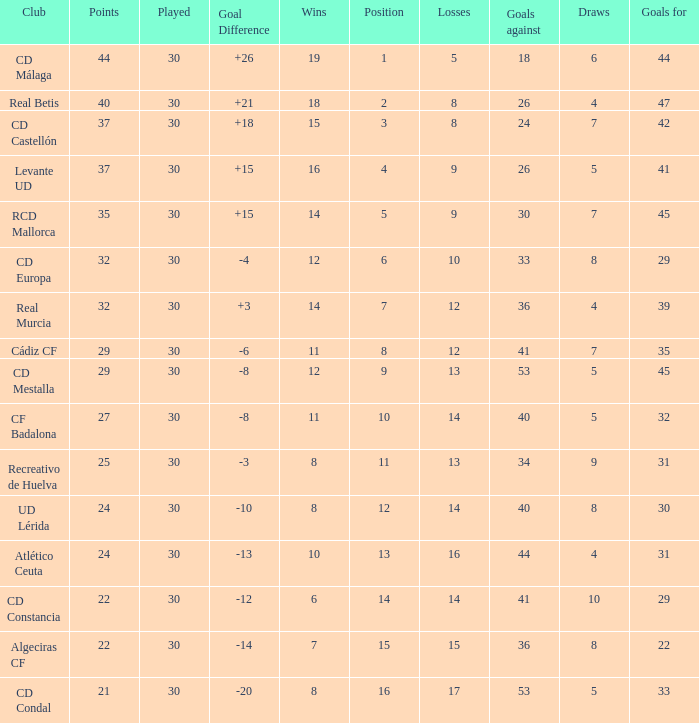When the goal difference was -8 and the position was under 10, what was the total number of losses? 1.0. 